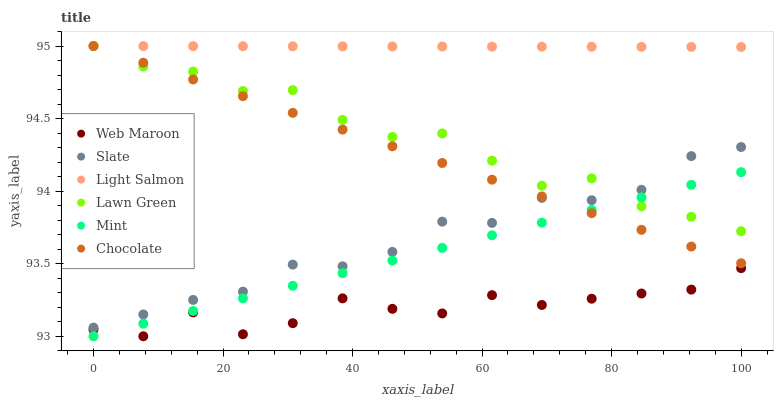Does Web Maroon have the minimum area under the curve?
Answer yes or no. Yes. Does Light Salmon have the maximum area under the curve?
Answer yes or no. Yes. Does Slate have the minimum area under the curve?
Answer yes or no. No. Does Slate have the maximum area under the curve?
Answer yes or no. No. Is Mint the smoothest?
Answer yes or no. Yes. Is Web Maroon the roughest?
Answer yes or no. Yes. Is Light Salmon the smoothest?
Answer yes or no. No. Is Light Salmon the roughest?
Answer yes or no. No. Does Web Maroon have the lowest value?
Answer yes or no. Yes. Does Slate have the lowest value?
Answer yes or no. No. Does Chocolate have the highest value?
Answer yes or no. Yes. Does Slate have the highest value?
Answer yes or no. No. Is Web Maroon less than Light Salmon?
Answer yes or no. Yes. Is Slate greater than Mint?
Answer yes or no. Yes. Does Slate intersect Lawn Green?
Answer yes or no. Yes. Is Slate less than Lawn Green?
Answer yes or no. No. Is Slate greater than Lawn Green?
Answer yes or no. No. Does Web Maroon intersect Light Salmon?
Answer yes or no. No. 